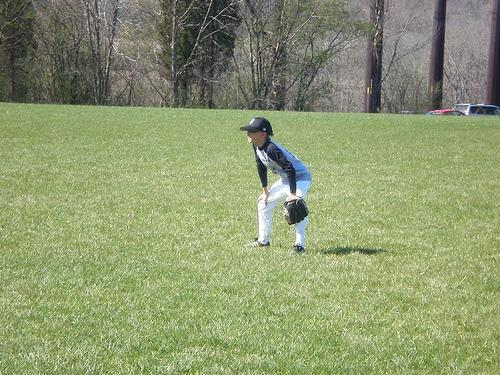What aspect of the game is being shown here? Please explain your reasoning. fielding. The aspect is fielding. 